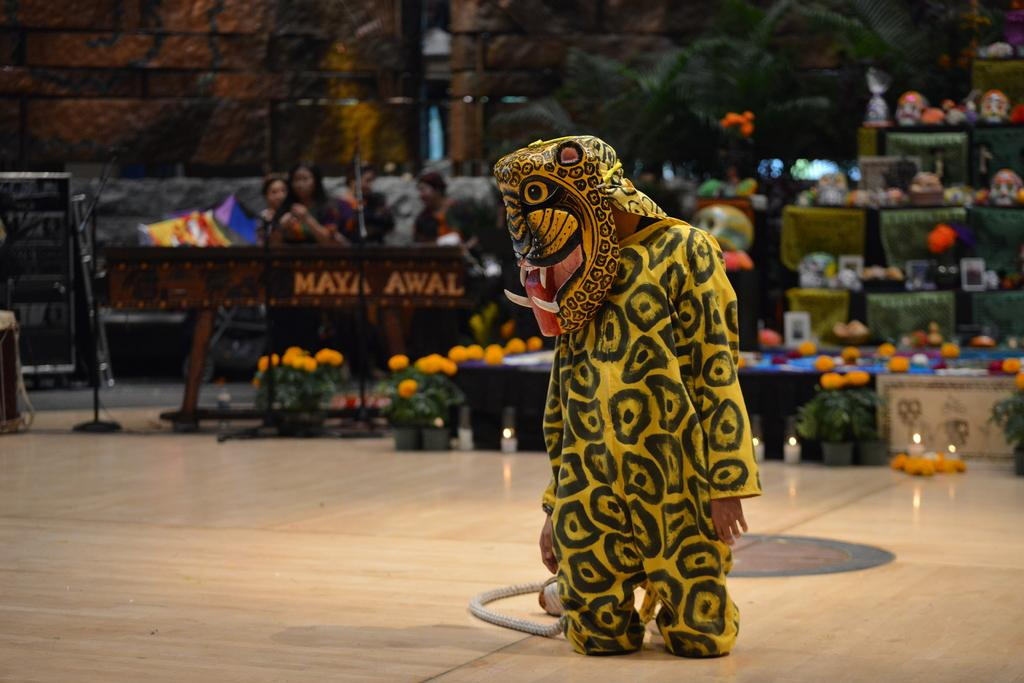What is the man in the image wearing? The man in the image is wearing a yellow costume. What can be seen in the image besides the man? Flower pots are visible in the image. How are the objects arranged in the image? There are objects arranged in the image. Where are the people sitting in the image? People are sitting on the left side of the image. What story does the rock in the image tell? There is no rock present in the image, so it cannot tell a story. 